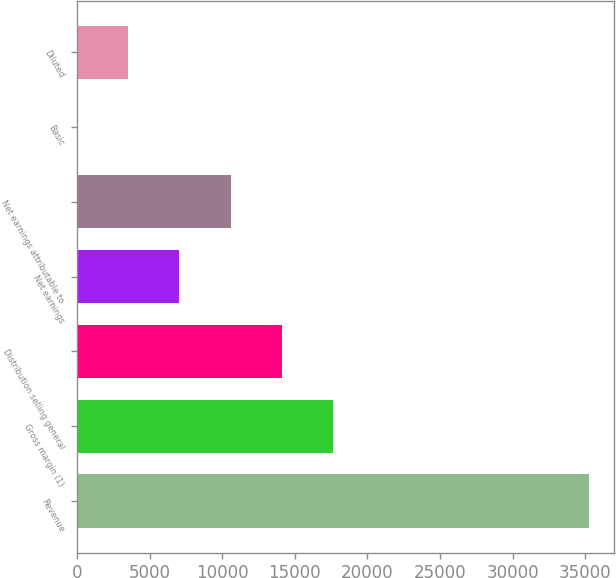Convert chart. <chart><loc_0><loc_0><loc_500><loc_500><bar_chart><fcel>Revenue<fcel>Gross margin (1)<fcel>Distribution selling general<fcel>Net earnings<fcel>Net earnings attributable to<fcel>Basic<fcel>Diluted<nl><fcel>35228<fcel>17614.5<fcel>14091.8<fcel>7046.39<fcel>10569.1<fcel>0.99<fcel>3523.69<nl></chart> 